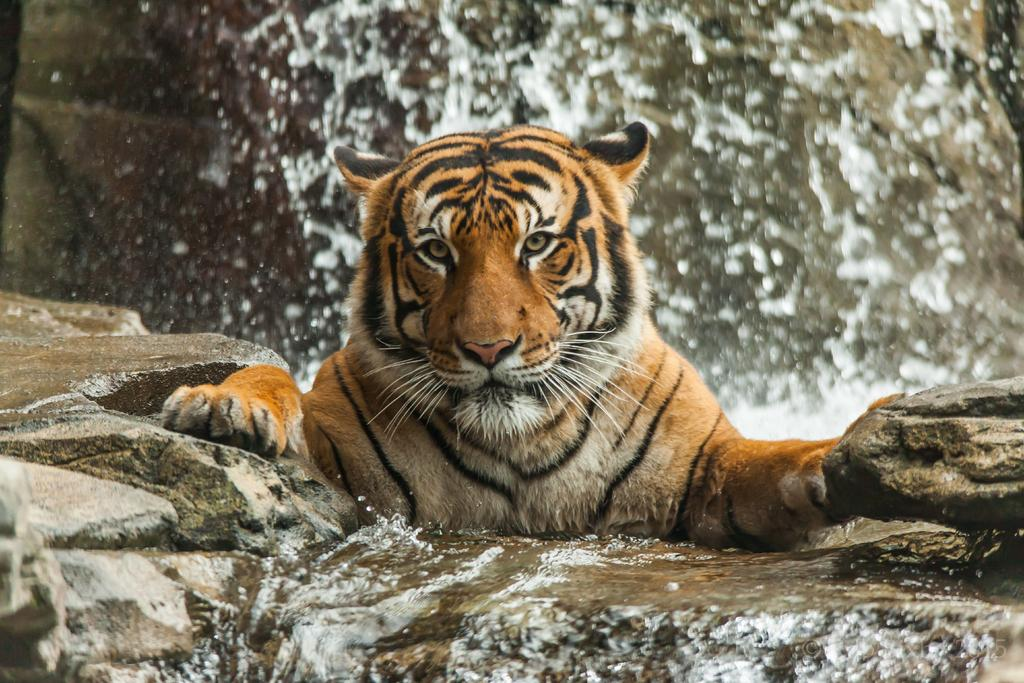What animal is the main subject of the picture? There is a tiger in the picture. What is the tiger doing in the picture? The tiger is staring. What can be seen on the right side of the picture? There is a rock on the right side of the picture. What is visible at the bottom of the picture? There is water at the bottom of the picture. How many afterthoughts are present in the picture? There is no mention of afterthoughts in the picture, so it cannot be determined how many are present. What type of giants can be seen interacting with the tiger in the picture? There are no giants present in the picture; it only features a tiger, a rock, and water. 